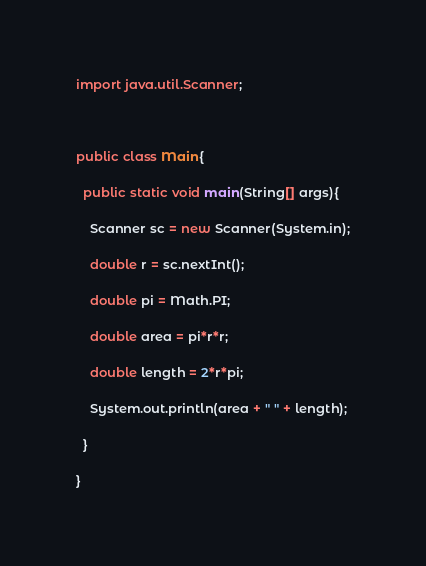<code> <loc_0><loc_0><loc_500><loc_500><_Java_>

import java.util.Scanner;



public class Main{

  public static void main(String[] args){

    Scanner sc = new Scanner(System.in);

    double r = sc.nextInt();

    double pi = Math.PI;

    double area = pi*r*r;

    double length = 2*r*pi;

    System.out.println(area + " " + length);

  }

}</code> 